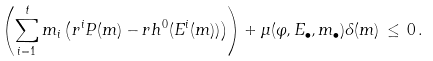<formula> <loc_0><loc_0><loc_500><loc_500>\left ( \sum _ { i = 1 } ^ { t } m _ { i } \left ( r ^ { i } P ( m ) - r h ^ { 0 } ( E ^ { i } ( m ) ) \right ) \right ) + \mu ( \varphi , E _ { \bullet } , m _ { \bullet } ) \delta ( m ) \, \leq \, 0 \, .</formula> 